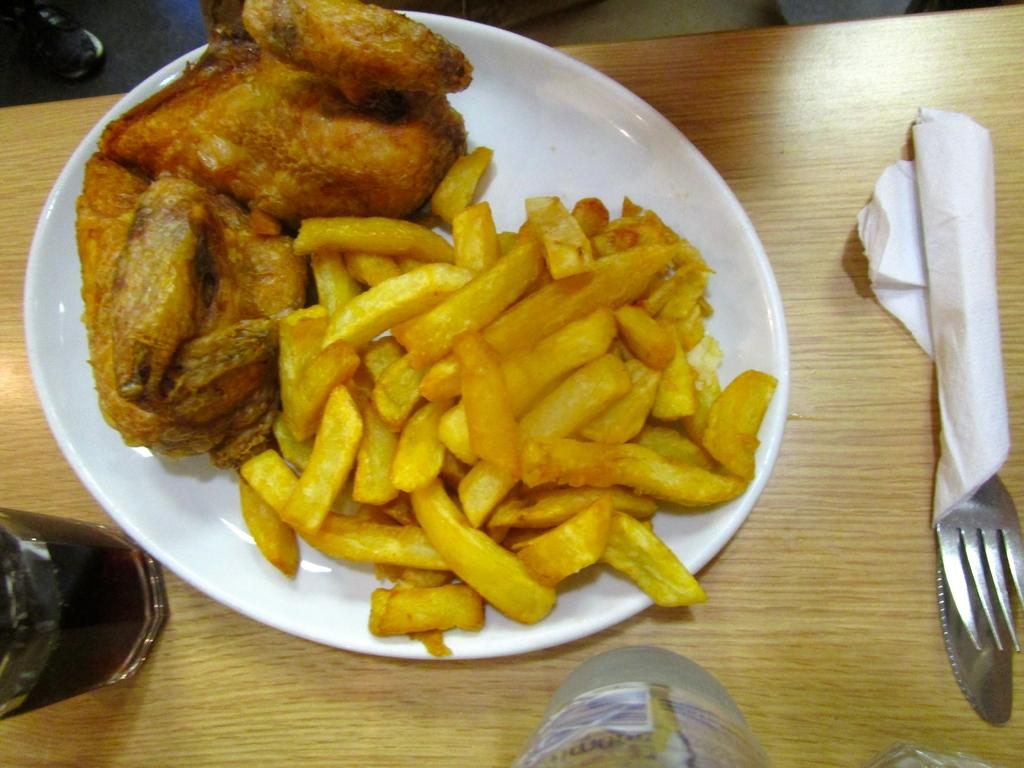What is on the plate that is visible in the image? There is a plate with food items in the image. What is the plate placed on? The plate is on a wooden table. What can be seen in the glass in the image? There is a glass of drink in the image. What is the bottle in the image used for? The bottle in the image is likely used for holding a drink or liquid. What is the fork in the image used for, and what is it resting on? The fork in the image is used for eating, and it is resting on a tissue. What religion is being practiced in the image? There is no indication of any religious practice in the image. How many quinces are visible in the image? There are no quinces present in the image. 